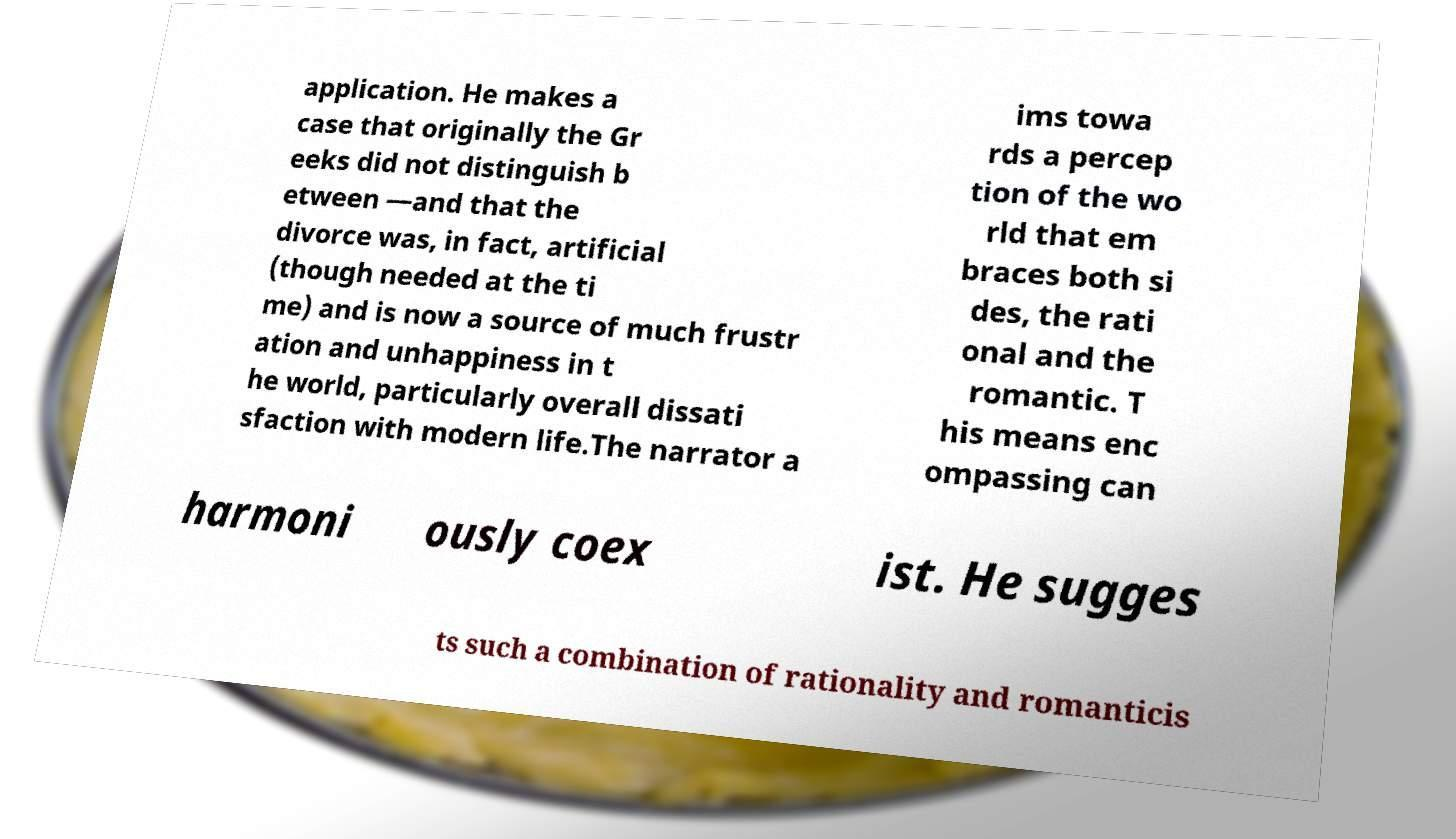Could you extract and type out the text from this image? application. He makes a case that originally the Gr eeks did not distinguish b etween —and that the divorce was, in fact, artificial (though needed at the ti me) and is now a source of much frustr ation and unhappiness in t he world, particularly overall dissati sfaction with modern life.The narrator a ims towa rds a percep tion of the wo rld that em braces both si des, the rati onal and the romantic. T his means enc ompassing can harmoni ously coex ist. He sugges ts such a combination of rationality and romanticis 